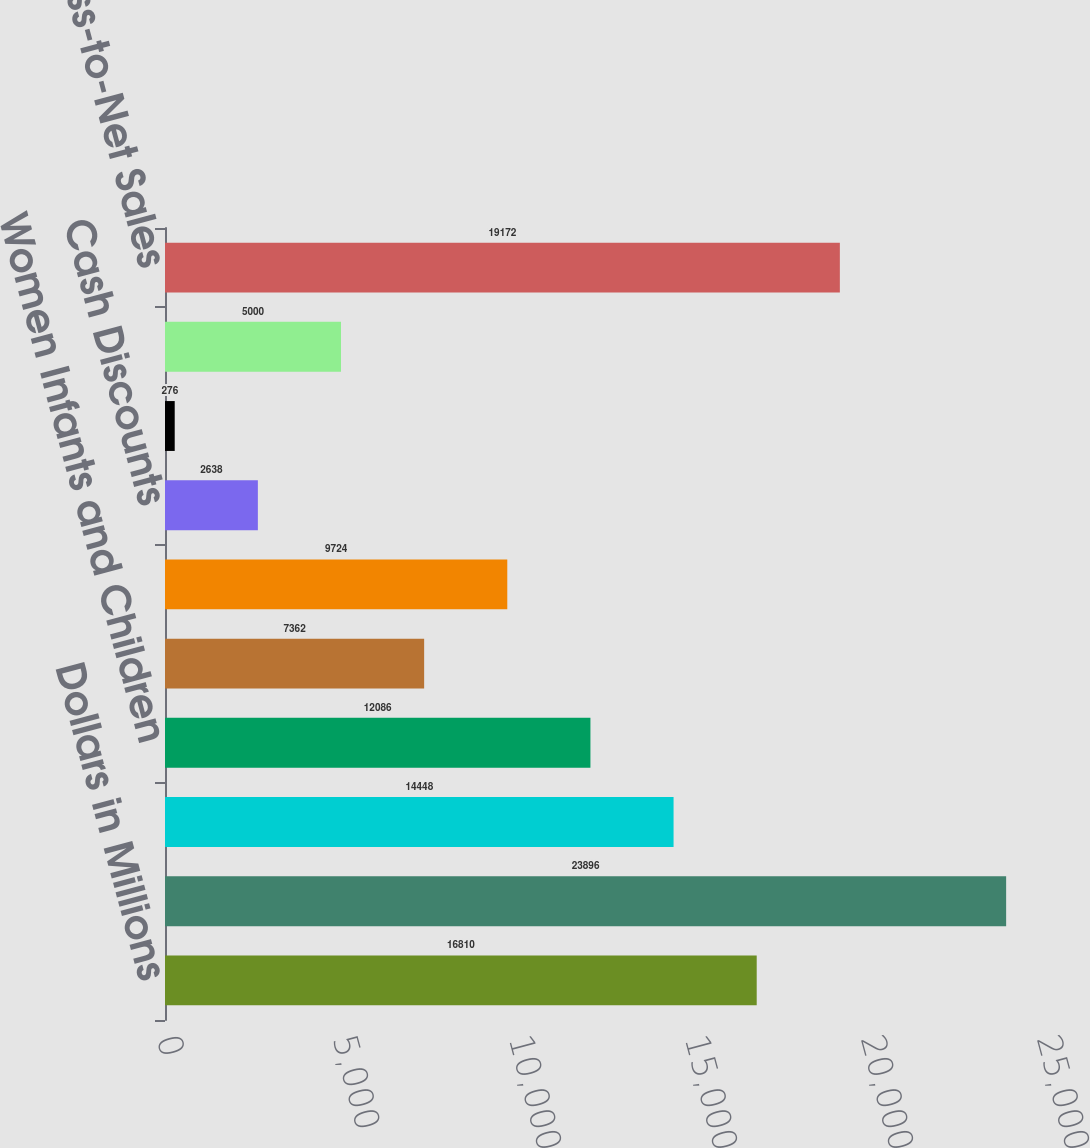<chart> <loc_0><loc_0><loc_500><loc_500><bar_chart><fcel>Dollars in Millions<fcel>Gross Sales<fcel>Prime Vendor Charge-Backs<fcel>Women Infants and Children<fcel>Managed Health Care Rebates<fcel>Medicaid Rebates<fcel>Cash Discounts<fcel>Sales Returns<fcel>Other Adjustments<fcel>Total Gross-to-Net Sales<nl><fcel>16810<fcel>23896<fcel>14448<fcel>12086<fcel>7362<fcel>9724<fcel>2638<fcel>276<fcel>5000<fcel>19172<nl></chart> 